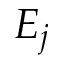Convert formula to latex. <formula><loc_0><loc_0><loc_500><loc_500>E _ { j }</formula> 